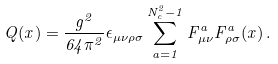Convert formula to latex. <formula><loc_0><loc_0><loc_500><loc_500>Q ( x ) = \frac { g ^ { 2 } } { 6 4 \pi ^ { 2 } } \epsilon _ { \mu \nu \rho \sigma } \sum _ { a = 1 } ^ { N _ { c } ^ { 2 } - 1 } F ^ { a } _ { \mu \nu } F ^ { a } _ { \rho \sigma } ( x ) \, .</formula> 